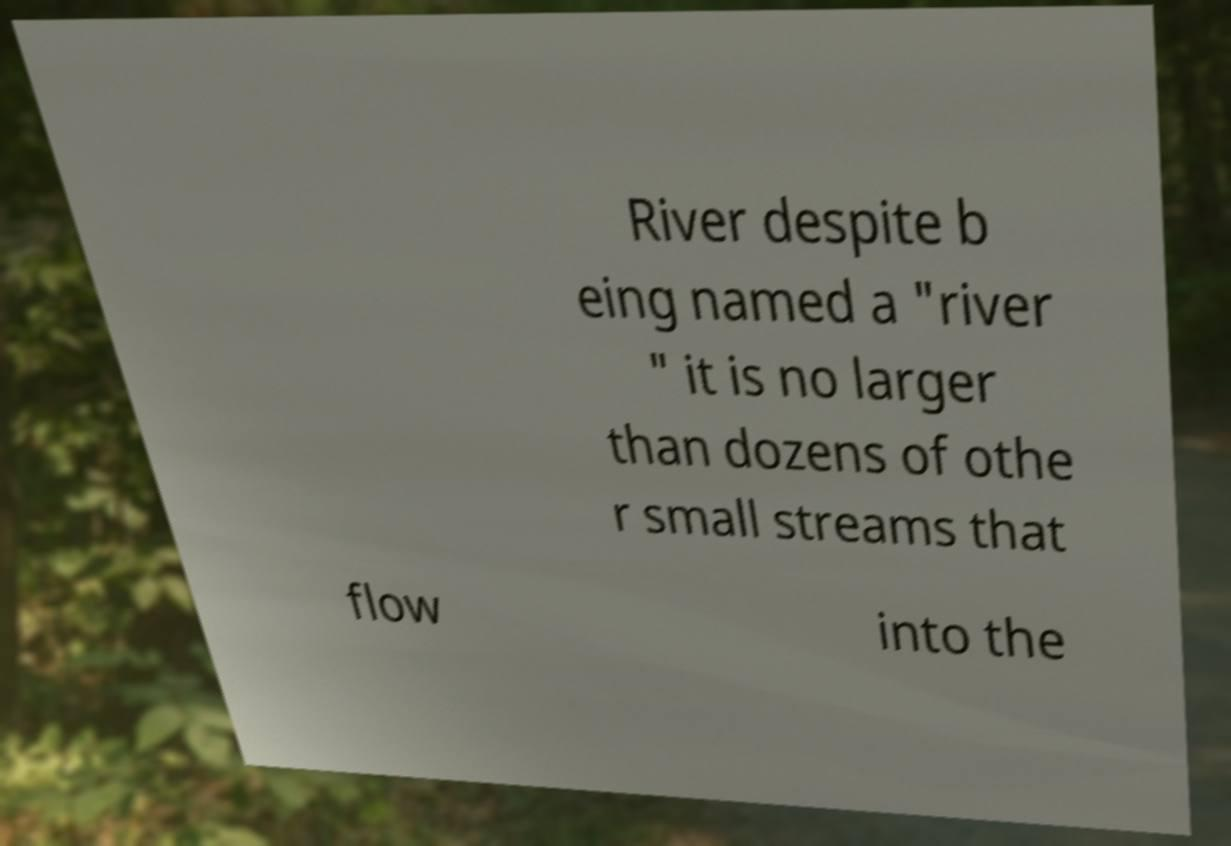Can you accurately transcribe the text from the provided image for me? River despite b eing named a "river " it is no larger than dozens of othe r small streams that flow into the 